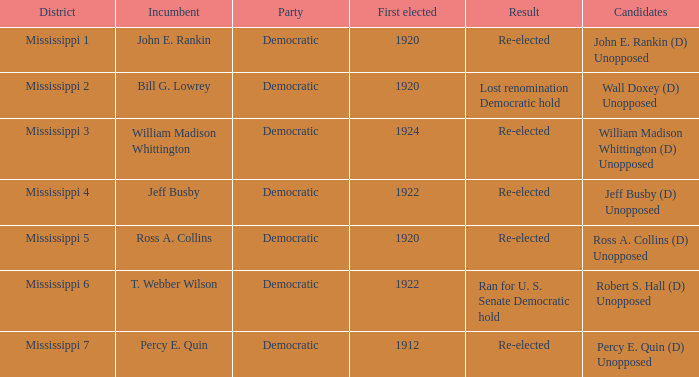What was the result of the election featuring william madison whittington? Re-elected. 